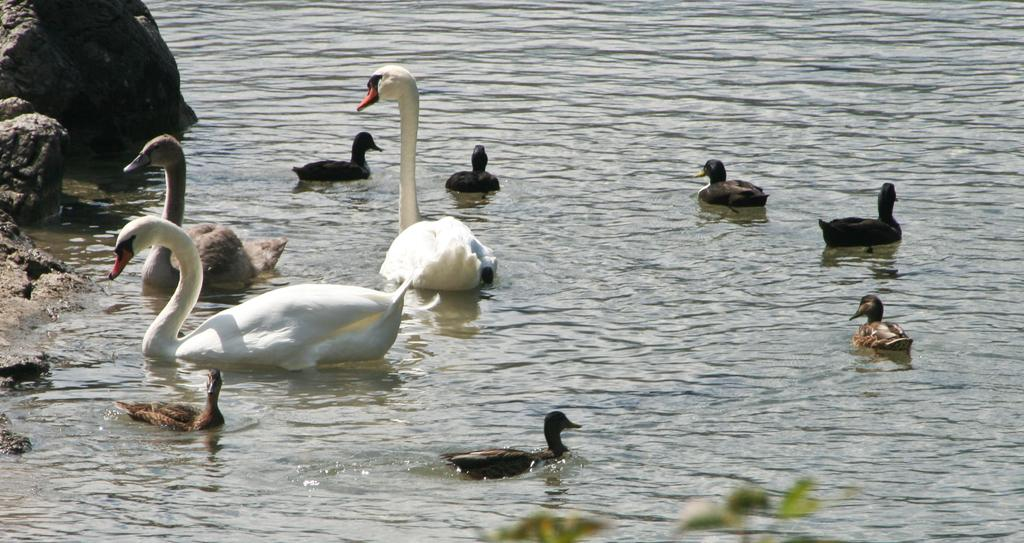What type of animals can be seen in the image? There are ducks in the water in the image. What can be found on the left side of the image? There are rocks on the left side of the image. What else is visible in the image besides the ducks and rocks? There are plants visible in the image. What rate of payment is required for the thing in the image? There is no rate of payment or thing present in the image; it features ducks in the water, rocks, and plants. 